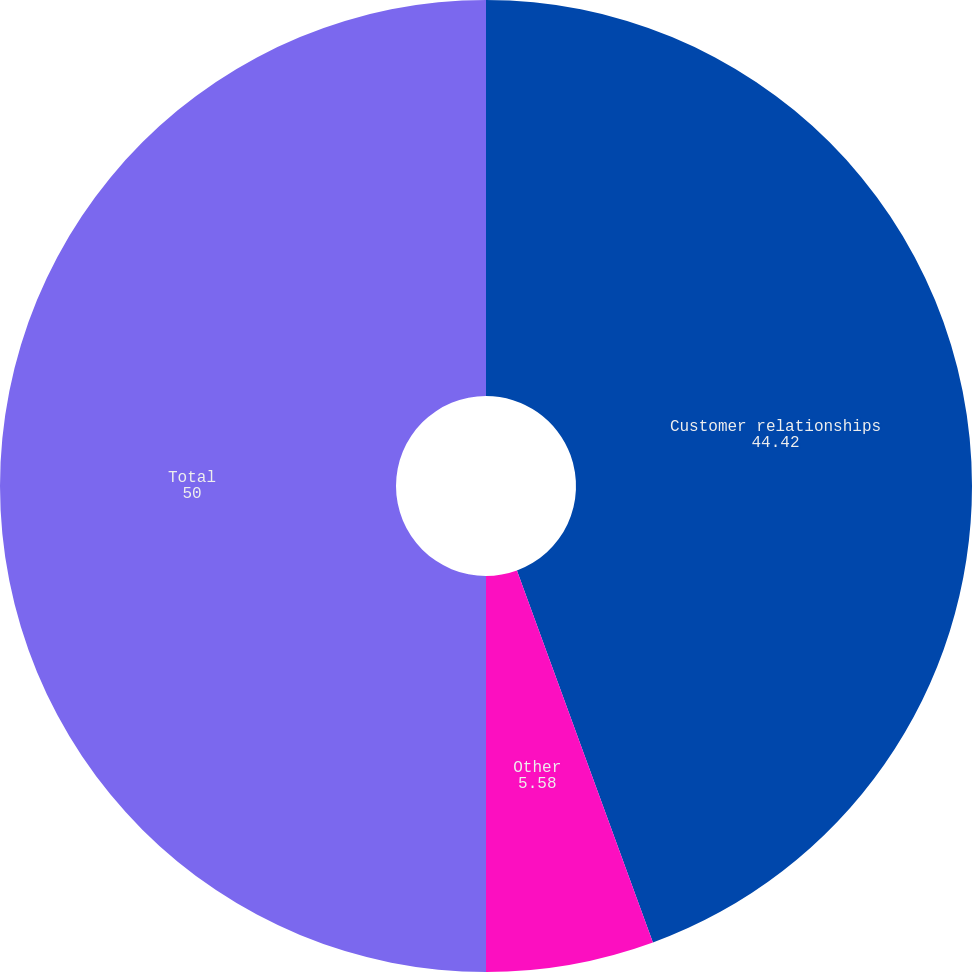Convert chart. <chart><loc_0><loc_0><loc_500><loc_500><pie_chart><fcel>Customer relationships<fcel>Other<fcel>Total<nl><fcel>44.42%<fcel>5.58%<fcel>50.0%<nl></chart> 